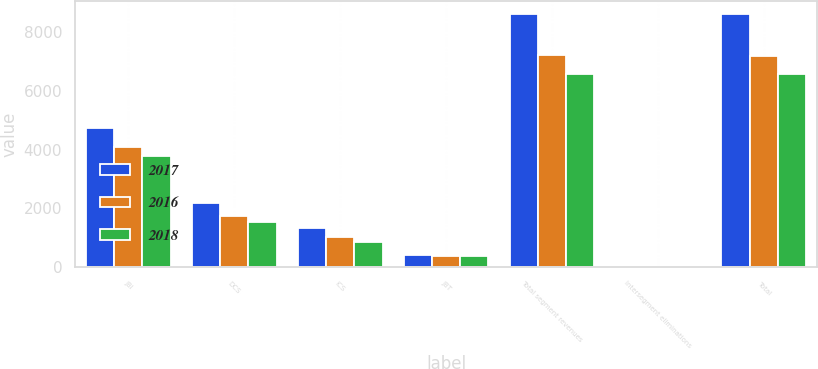Convert chart. <chart><loc_0><loc_0><loc_500><loc_500><stacked_bar_chart><ecel><fcel>JBI<fcel>DCS<fcel>ICS<fcel>JBT<fcel>Total segment revenues<fcel>Intersegment eliminations<fcel>Total<nl><fcel>2017<fcel>4717<fcel>2163<fcel>1335<fcel>417<fcel>8632<fcel>17<fcel>8615<nl><fcel>2016<fcel>4084<fcel>1719<fcel>1025<fcel>378<fcel>7206<fcel>16<fcel>7190<nl><fcel>2018<fcel>3796<fcel>1533<fcel>852<fcel>388<fcel>6569<fcel>14<fcel>6555<nl></chart> 